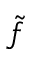Convert formula to latex. <formula><loc_0><loc_0><loc_500><loc_500>\tilde { f }</formula> 